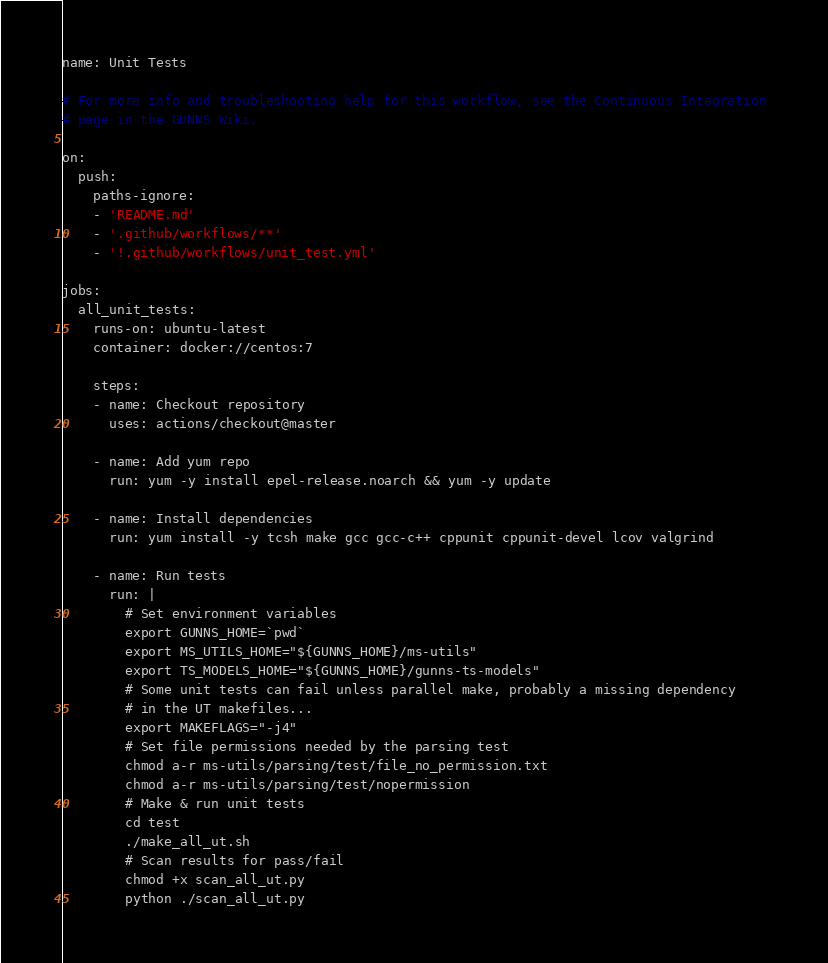Convert code to text. <code><loc_0><loc_0><loc_500><loc_500><_YAML_>name: Unit Tests

# For more info and troubleshooting help for this workflow, see the Continuous Integration 
# page in the GUNNS Wiki.

on:
  push:
    paths-ignore:
    - 'README.md'
    - '.github/workflows/**'
    - '!.github/workflows/unit_test.yml'

jobs:
  all_unit_tests:
    runs-on: ubuntu-latest
    container: docker://centos:7

    steps:
    - name: Checkout repository
      uses: actions/checkout@master

    - name: Add yum repo
      run: yum -y install epel-release.noarch && yum -y update

    - name: Install dependencies
      run: yum install -y tcsh make gcc gcc-c++ cppunit cppunit-devel lcov valgrind

    - name: Run tests
      run: |
        # Set environment variables
        export GUNNS_HOME=`pwd`
        export MS_UTILS_HOME="${GUNNS_HOME}/ms-utils"
        export TS_MODELS_HOME="${GUNNS_HOME}/gunns-ts-models"
        # Some unit tests can fail unless parallel make, probably a missing dependency
        # in the UT makefiles...
        export MAKEFLAGS="-j4"
        # Set file permissions needed by the parsing test
        chmod a-r ms-utils/parsing/test/file_no_permission.txt
        chmod a-r ms-utils/parsing/test/nopermission
        # Make & run unit tests
        cd test
        ./make_all_ut.sh
        # Scan results for pass/fail
        chmod +x scan_all_ut.py
        python ./scan_all_ut.py

</code> 